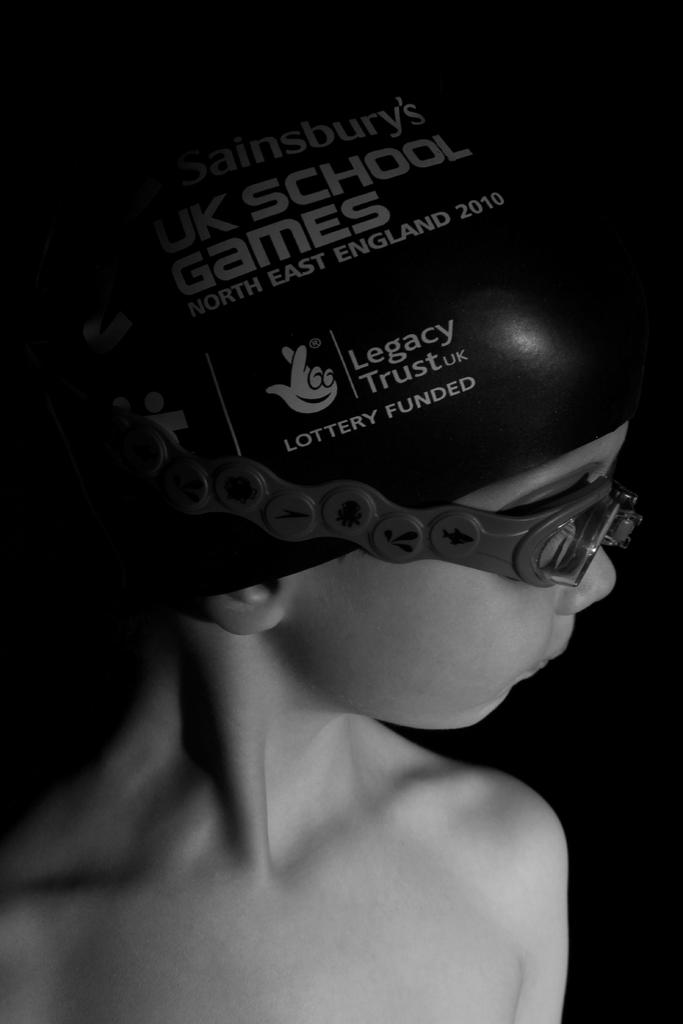What is the color scheme of the image? The image is black and white. Who is present in the image? There is a boy in the image. What accessory is the boy wearing on his face? The boy is wearing glasses. What type of headwear is the boy wearing? The boy is wearing a cap. What is written or printed on the cap? The cap has text on it. How many girls are present in the image? There are no girls present in the image; it features a boy. What type of transport is visible in the image? There is no transport visible in the image. What is the boy using to cook in the image? There is no pot or cooking activity present in the image. 